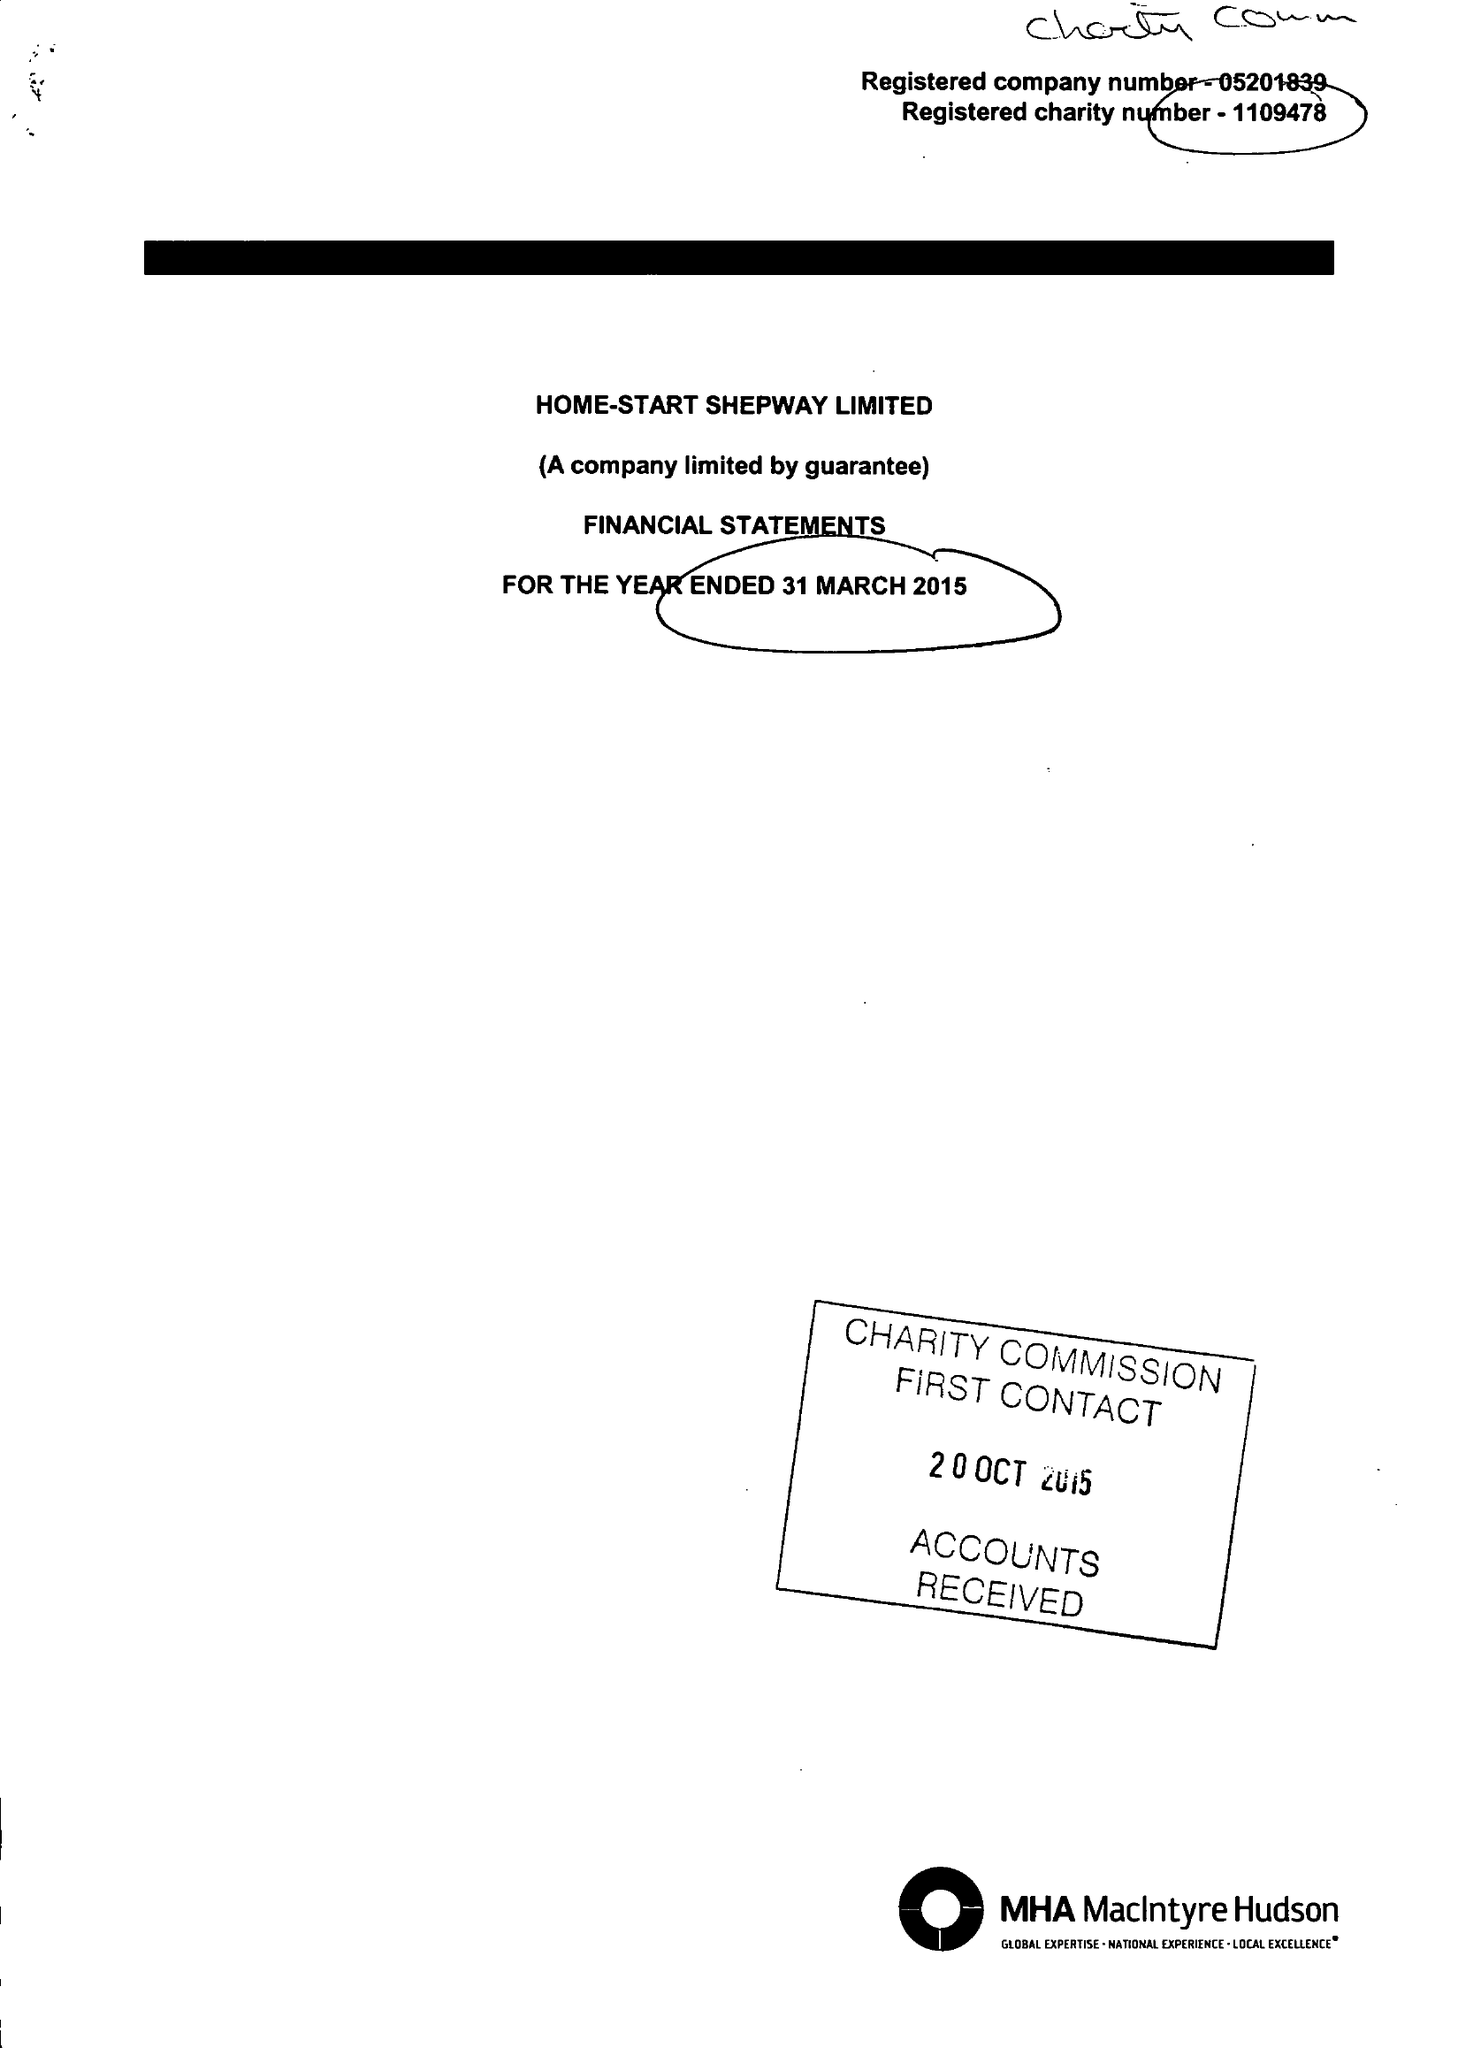What is the value for the charity_name?
Answer the question using a single word or phrase. Home-Start Shepway Ltd. 